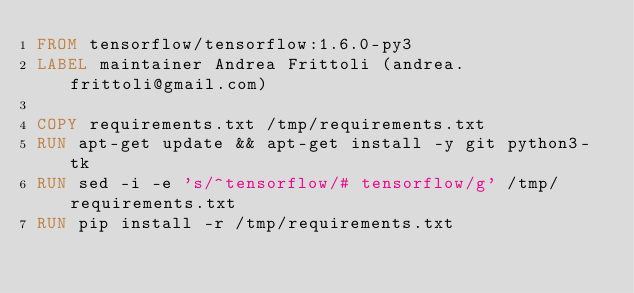Convert code to text. <code><loc_0><loc_0><loc_500><loc_500><_Dockerfile_>FROM tensorflow/tensorflow:1.6.0-py3
LABEL maintainer Andrea Frittoli (andrea.frittoli@gmail.com)

COPY requirements.txt /tmp/requirements.txt
RUN apt-get update && apt-get install -y git python3-tk
RUN sed -i -e 's/^tensorflow/# tensorflow/g' /tmp/requirements.txt
RUN pip install -r /tmp/requirements.txt
</code> 